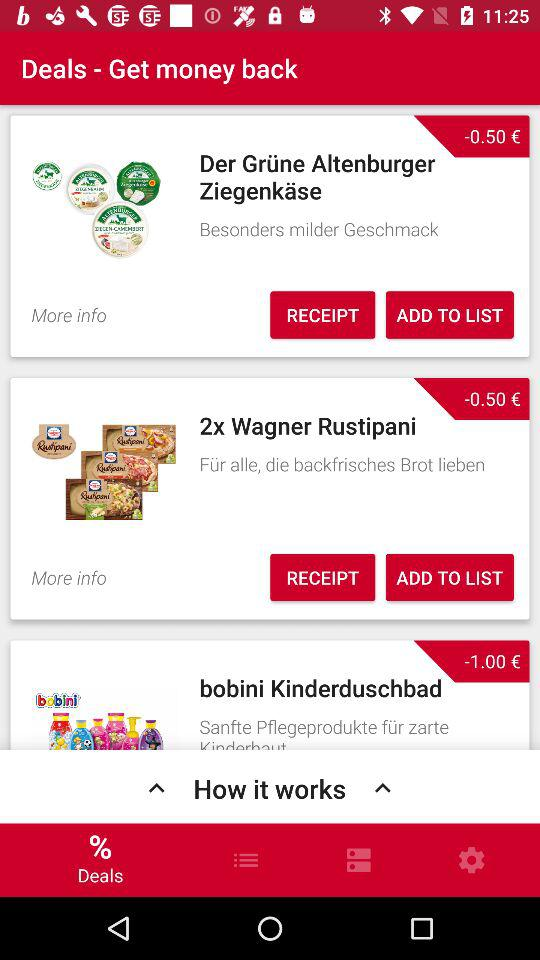How much do I save with all these deals?
Answer the question using a single word or phrase. -2.00 € 